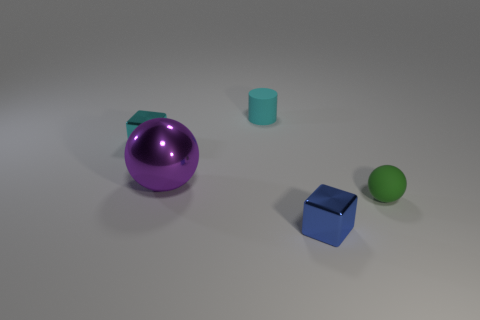Add 4 tiny red cubes. How many objects exist? 9 Subtract all cylinders. How many objects are left? 4 Subtract 1 cyan cylinders. How many objects are left? 4 Subtract all cyan matte blocks. Subtract all cylinders. How many objects are left? 4 Add 1 rubber balls. How many rubber balls are left? 2 Add 5 cyan rubber cylinders. How many cyan rubber cylinders exist? 6 